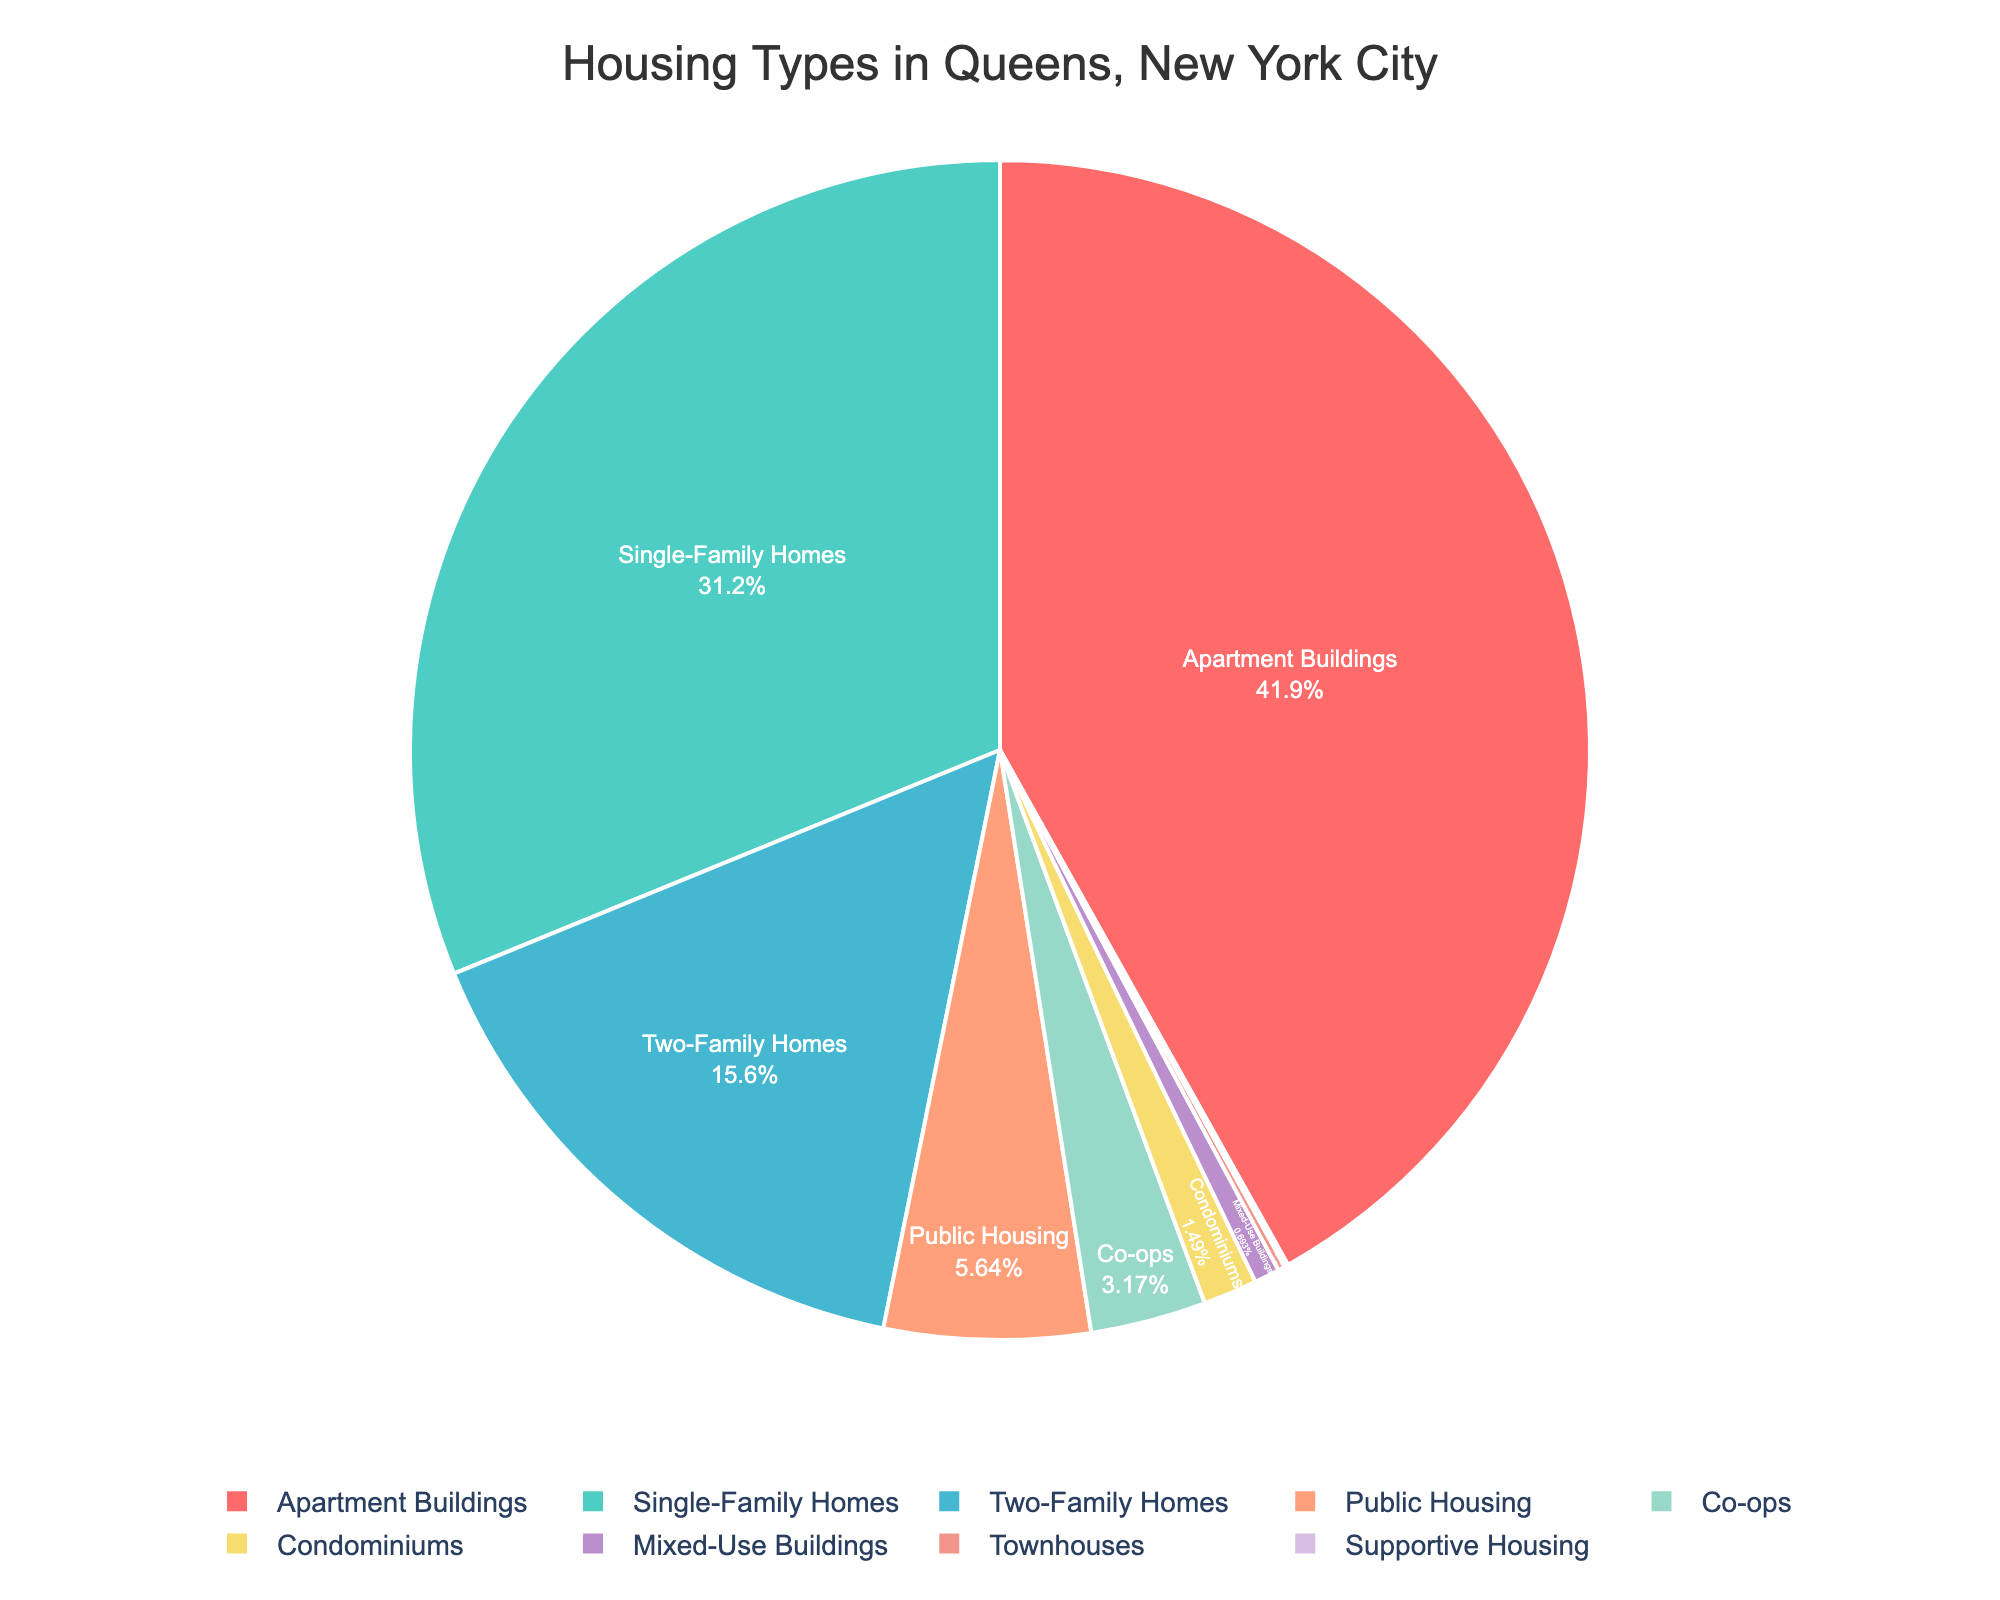What's the most common housing type in Queens? The most prominent segment in the pie chart represents the most common housing type. Here, the largest segment is "Apartment Buildings," which covers 42.3% of the chart.
Answer: Apartment Buildings How many housing types make up less than 10% each? To find this, we count the segments that are less than 10%. These include: Public Housing (5.7%), Co-ops (3.2%), Condominiums (1.5%), Mixed-Use Buildings (0.7%), Townhouses (0.2%), and Supportive Housing (0.1%). There are six segments in total.
Answer: 6 Which has a larger percentage, Single-Family Homes or Two-Family Homes? By comparing the percentages, Single-Family Homes have 31.5% and Two-Family Homes have 15.8%. Single-Family Homes have a larger percentage.
Answer: Single-Family Homes What percentage of housing types are apartments and public housing combined? To find the combined percentage, add the percentages of Apartment Buildings (42.3%) and Public Housing (5.7%). The combined total is 42.3 + 5.7 = 48.0%.
Answer: 48.0% Which housing type has the smallest representation, and what color represents it? The smallest slice corresponds to Supportive Housing, with just 0.1%. The slice is purple in the pie chart.
Answer: Supportive Housing; purple What is the percentage difference between Single-Family Homes and Public Housing? Subtract the percentage of Public Housing (5.7%) from Single-Family Homes (31.5%). The difference is 31.5 - 5.7 = 25.8%.
Answer: 25.8% What is the total percentage of housing types that are some form of multi-family homes (Apartment Buildings, Two-Family Homes, and Co-ops)? Adding up the percentages for Apartment Buildings (42.3%), Two-Family Homes (15.8%), and Co-ops (3.2%) gives us 42.3 + 15.8 + 3.2 = 61.3%.
Answer: 61.3% Are there more percent of Single-Family Homes or both Co-ops and Condominiums combined? First, sum the percentages of Co-ops (3.2%) and Condominiums (1.5%), which is 3.2 + 1.5 = 4.7%. Single-Family Homes alone have 31.5%, which is significantly larger.
Answer: Single-Family Homes What color represents Two-Family Homes? The segment representing Two-Family Homes is blue in the pie chart.
Answer: Blue 